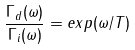<formula> <loc_0><loc_0><loc_500><loc_500>\frac { \Gamma _ { d } ( \omega ) } { \Gamma _ { i } ( \omega ) } = e x p ( \omega / T )</formula> 